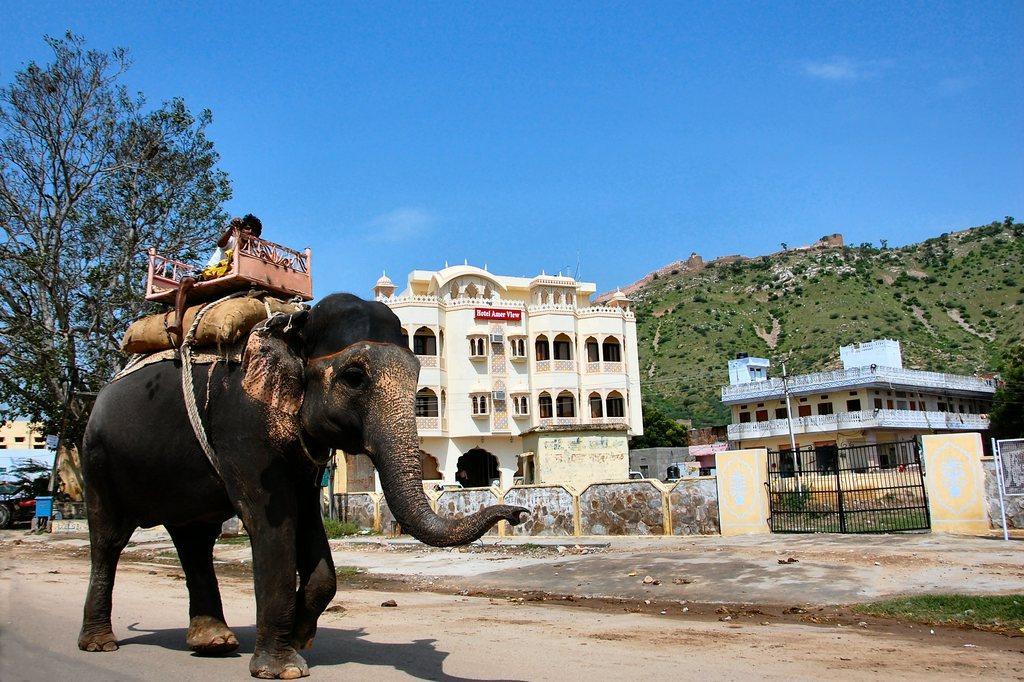Describe this image in one or two sentences. In this image we can see a man riding an elephant on the road. We can also see some buildings with windows, a sign board, fence, gate and doors. On the left side we can see some trees. On the backside we can see a group of trees on the hill and the sky which looks cloudy. 